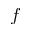<formula> <loc_0><loc_0><loc_500><loc_500>f</formula> 